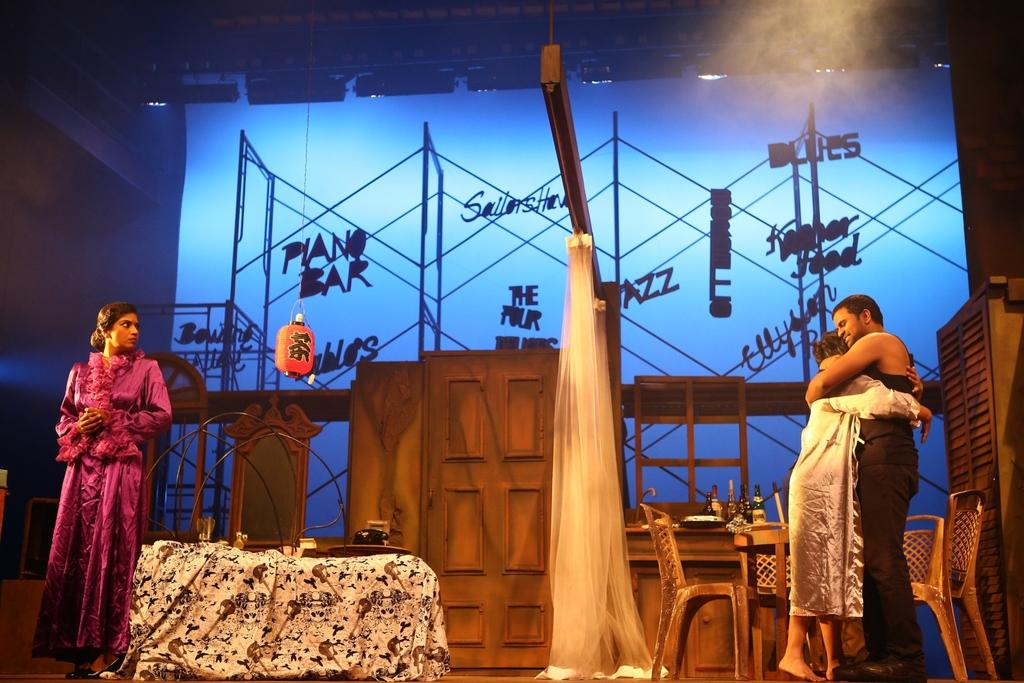What type of furniture is present in the image? There are chairs in the image. What type of covering is present in the image? There is a curtain in the image. How many people are visible in the image? There are three people in the image. What are the people doing in the image? The people appear to be performing a role play on a platform. Can you see a rabbit performing alongside the people in the image? No, there is no rabbit present in the image. 